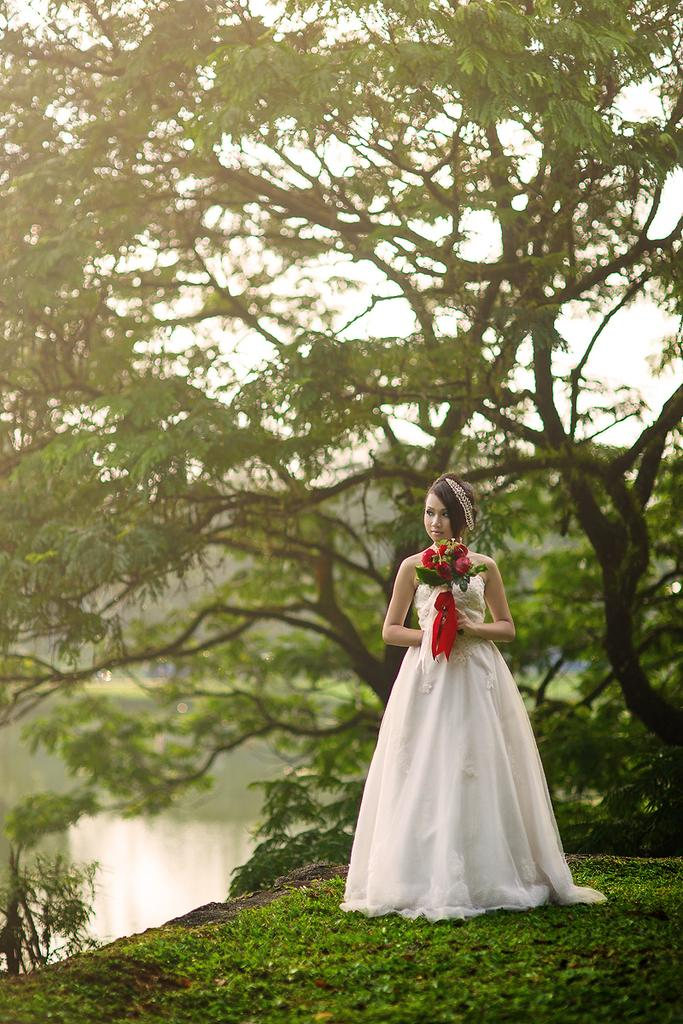Who is the main subject in the image? There is a woman in the image. What is the woman doing in the image? The woman is standing. What is the woman holding in the image? The woman is holding red color roses. What can be seen in the background of the image? There are trees and water visible in the background. What is the color of the sky in the image? The sky appears to be white in color. Where is the store located in the image? There is no store present in the image. What day of the week is it in the image? The day of the week cannot be determined from the image. 